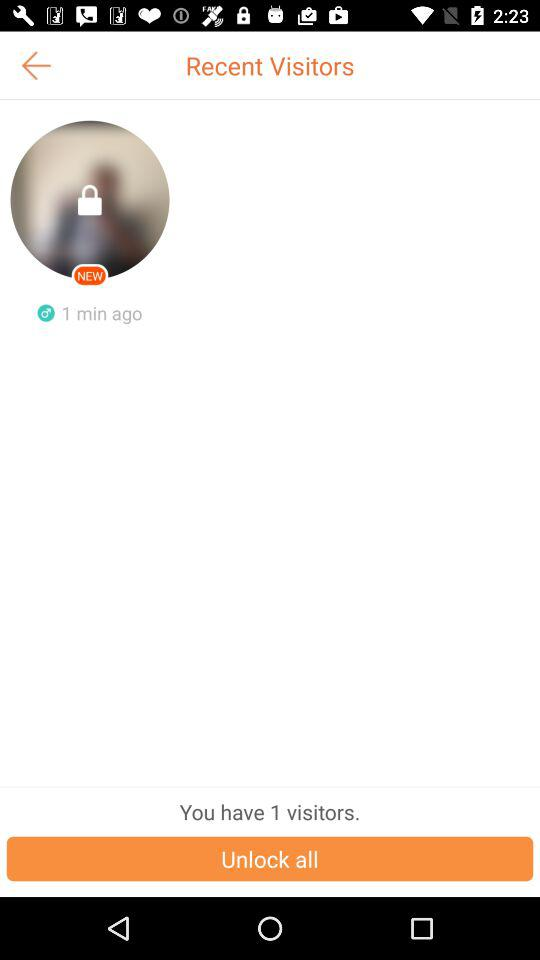How many minutes ago was the last visitor?
Answer the question using a single word or phrase. 1 